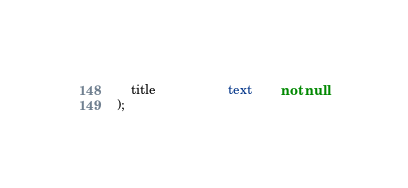<code> <loc_0><loc_0><loc_500><loc_500><_SQL_>	title					text		not null
);
</code> 